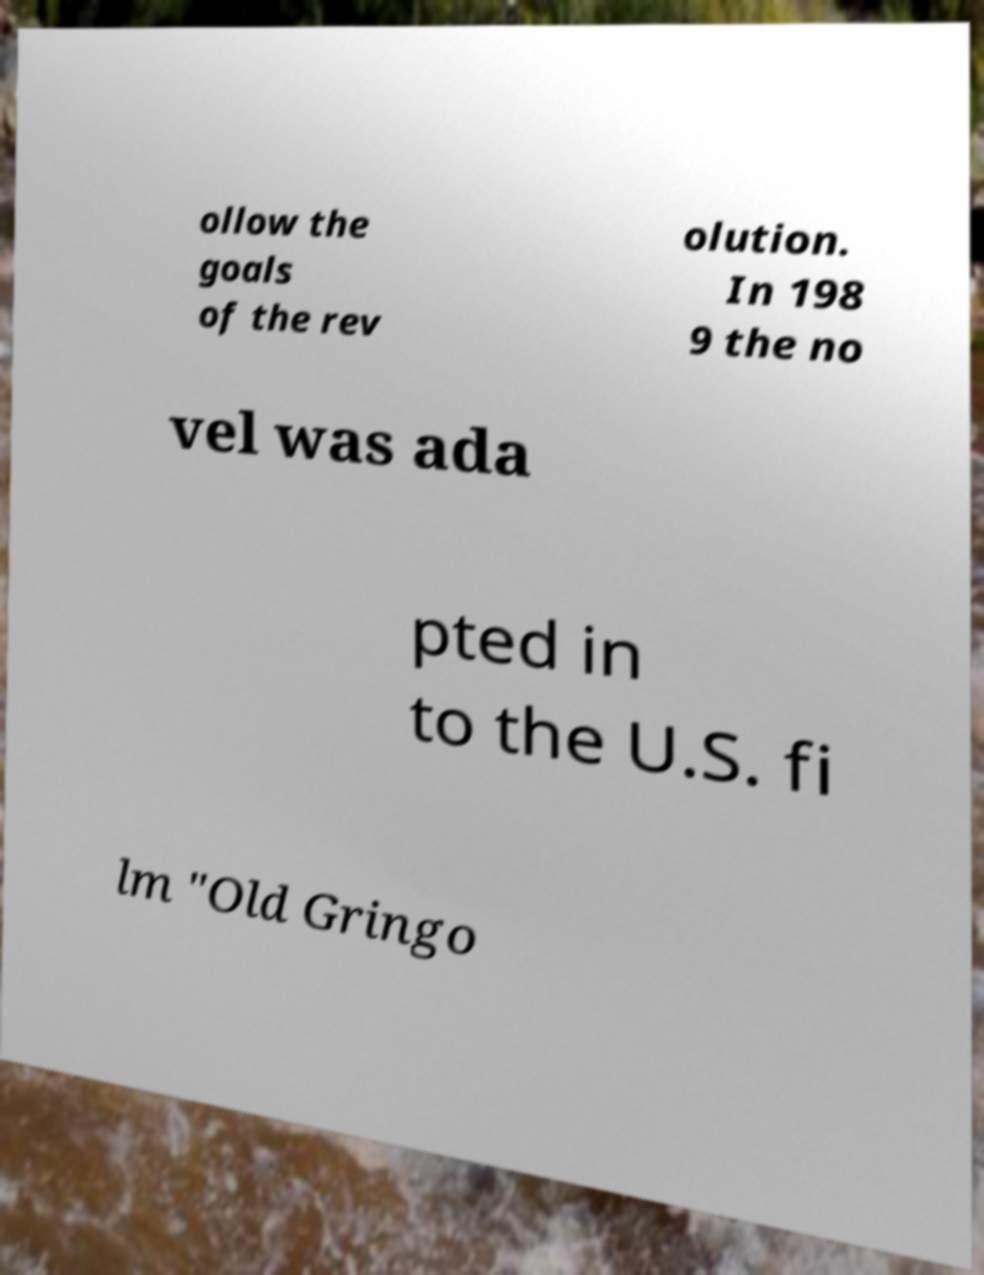I need the written content from this picture converted into text. Can you do that? ollow the goals of the rev olution. In 198 9 the no vel was ada pted in to the U.S. fi lm "Old Gringo 